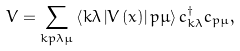Convert formula to latex. <formula><loc_0><loc_0><loc_500><loc_500>V = \sum _ { k p \lambda \mu } \left \langle k \lambda \left | V \left ( x \right ) \right | p \mu \right \rangle c _ { k \lambda } ^ { \dagger } c _ { p \mu } ,</formula> 